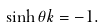Convert formula to latex. <formula><loc_0><loc_0><loc_500><loc_500>\sinh \theta & k = - 1 .</formula> 